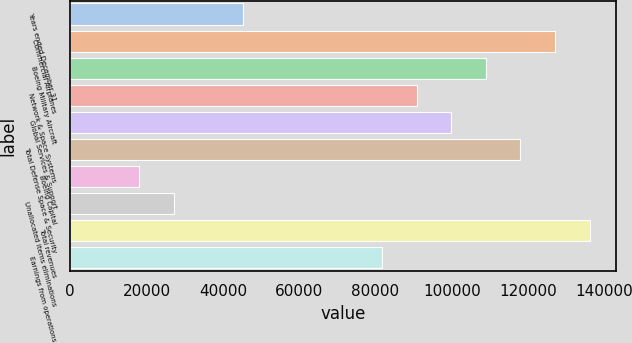Convert chart to OTSL. <chart><loc_0><loc_0><loc_500><loc_500><bar_chart><fcel>Years ended December 31<fcel>Commercial Airplanes<fcel>Boeing Military Aircraft<fcel>Network & Space Systems<fcel>Global Services & Support<fcel>Total Defense Space & Security<fcel>Boeing Capital<fcel>Unallocated items eliminations<fcel>Total revenues<fcel>Earnings from operations<nl><fcel>45382.5<fcel>127066<fcel>108914<fcel>90762<fcel>99837.9<fcel>117990<fcel>18154.8<fcel>27230.7<fcel>136142<fcel>81686.1<nl></chart> 